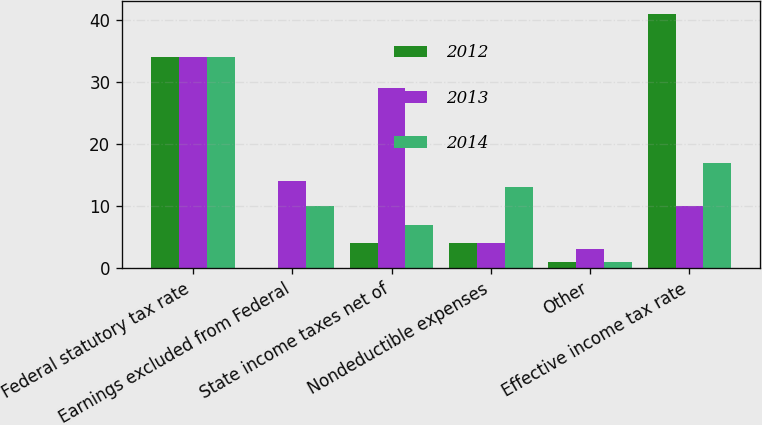Convert chart. <chart><loc_0><loc_0><loc_500><loc_500><stacked_bar_chart><ecel><fcel>Federal statutory tax rate<fcel>Earnings excluded from Federal<fcel>State income taxes net of<fcel>Nondeductible expenses<fcel>Other<fcel>Effective income tax rate<nl><fcel>2012<fcel>34<fcel>0<fcel>4<fcel>4<fcel>1<fcel>41<nl><fcel>2013<fcel>34<fcel>14<fcel>29<fcel>4<fcel>3<fcel>10<nl><fcel>2014<fcel>34<fcel>10<fcel>7<fcel>13<fcel>1<fcel>17<nl></chart> 